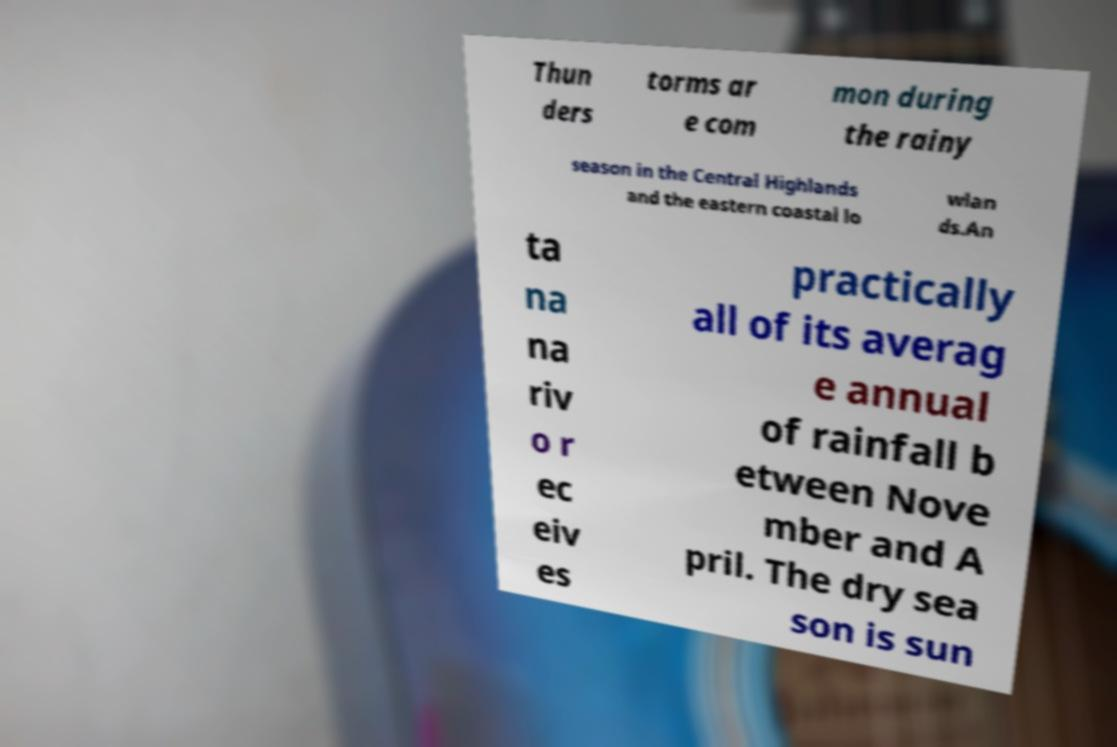What messages or text are displayed in this image? I need them in a readable, typed format. Thun ders torms ar e com mon during the rainy season in the Central Highlands and the eastern coastal lo wlan ds.An ta na na riv o r ec eiv es practically all of its averag e annual of rainfall b etween Nove mber and A pril. The dry sea son is sun 